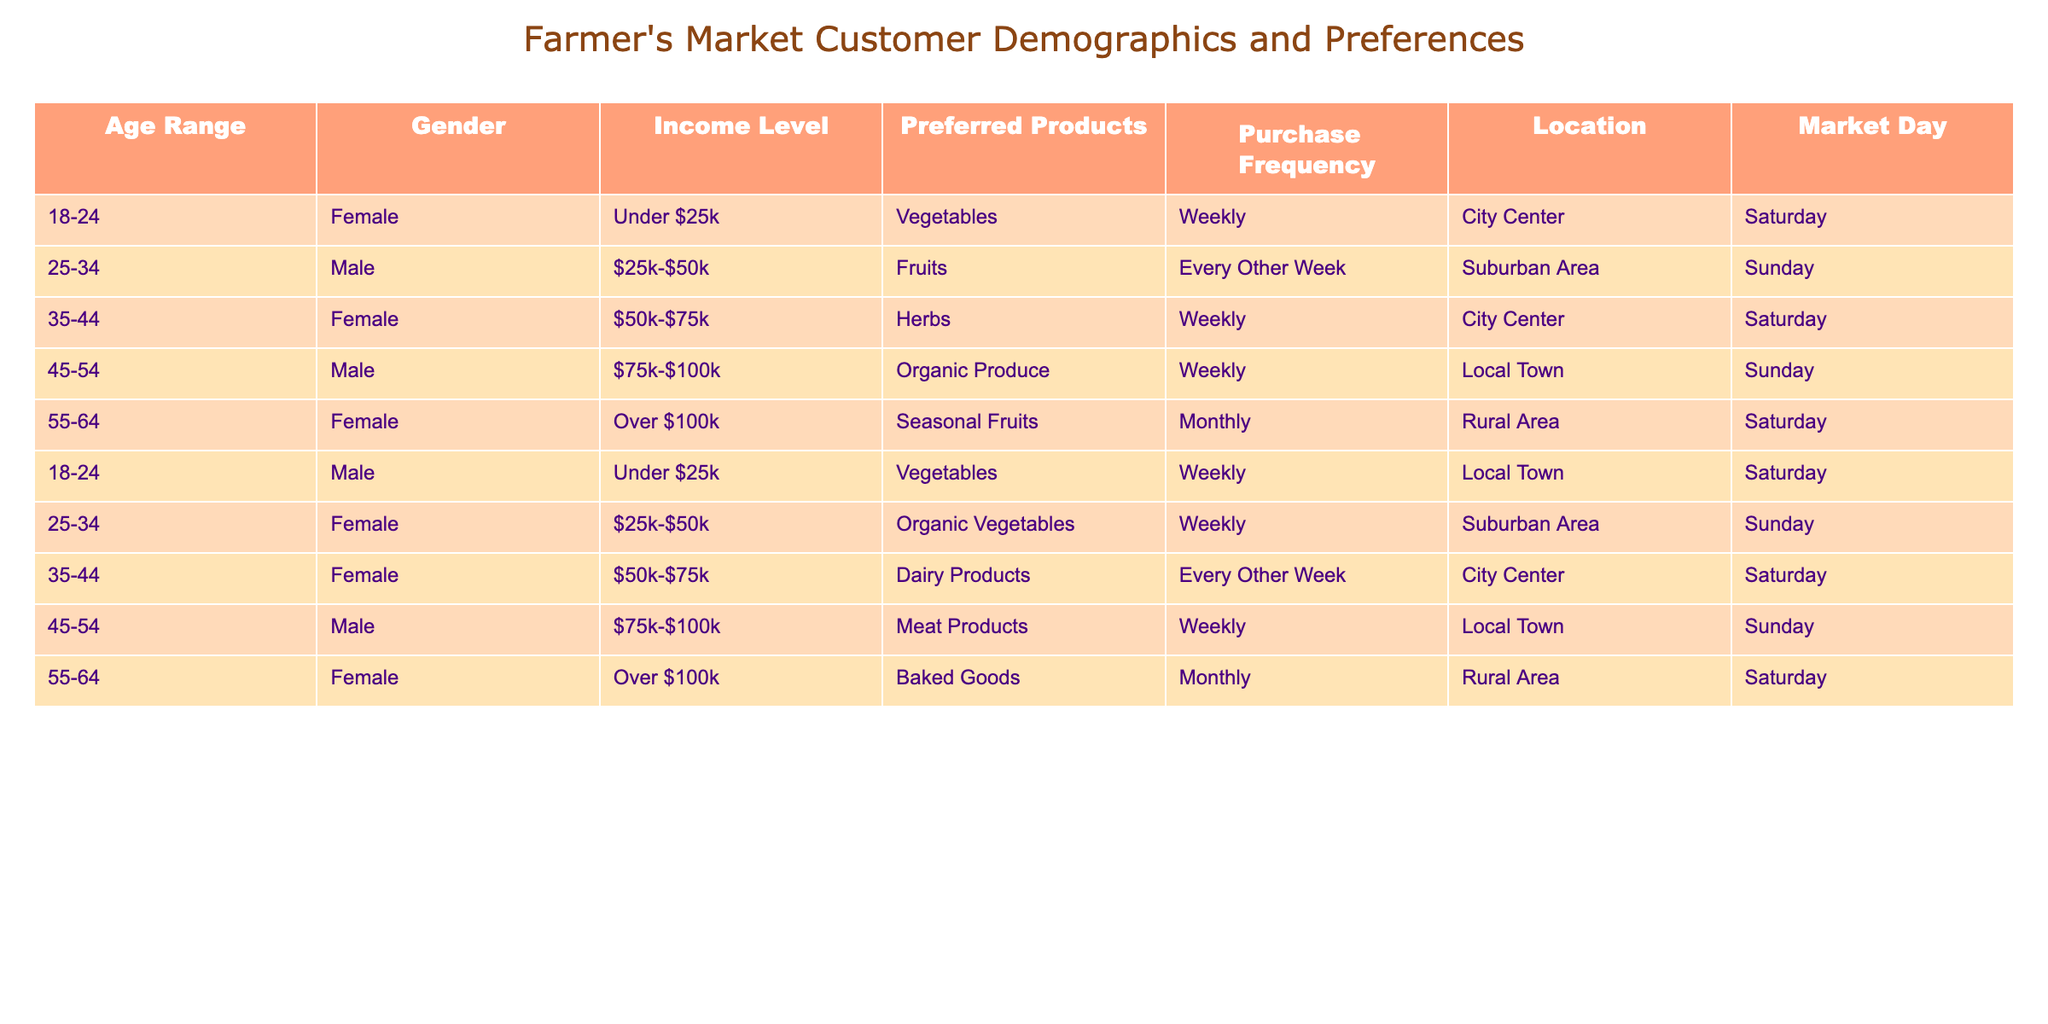What is the most preferred product among customers aged 25-34? To determine this, we look at the rows for the age range 25-34. There are two entries: one for males preferring fruits and another for females preferring organic vegetables. Hence, the most mentioned preferred product is fruits and organic vegetables. The phrasing is somewhat ambiguous as there are two entries so both can be considered.
Answer: Fruits and organic vegetables How many customers prefer vegetables as their primary product? From the table, we can see that there are two customers who prefer vegetables: one aged 18-24 (male) and one aged 18-24 (female). Thus, the total number of customers preferring vegetables is 2.
Answer: 2 Is there anyone who prefers seasonal fruits? We check the table for any entries mentioning seasonal fruits. There is one customer aged 55-64 (female) who specifies seasonal fruits as their preferred product. So the answer is yes, there is one.
Answer: Yes What is the average income level of customers who prefer dairy products? There is one entry for dairy products, which is from a female in the age range of 35-44, with an income level of $50k-$75k. Since there is only one customer, the average is the same as that income level: $50k-$75k. The calculation does not require additional averaging.
Answer: $50k-$75k What percentage of male customers shop weekly at farmer's markets? There are 5 male customers in total. Out of those, 3 (aged 45-54, 18-24, and 25-34) shop weekly. To find the percentage, we divide the number of males shopping weekly (3) by the total number of males (5) and multiply by 100: (3/5) * 100 = 60%.
Answer: 60% 